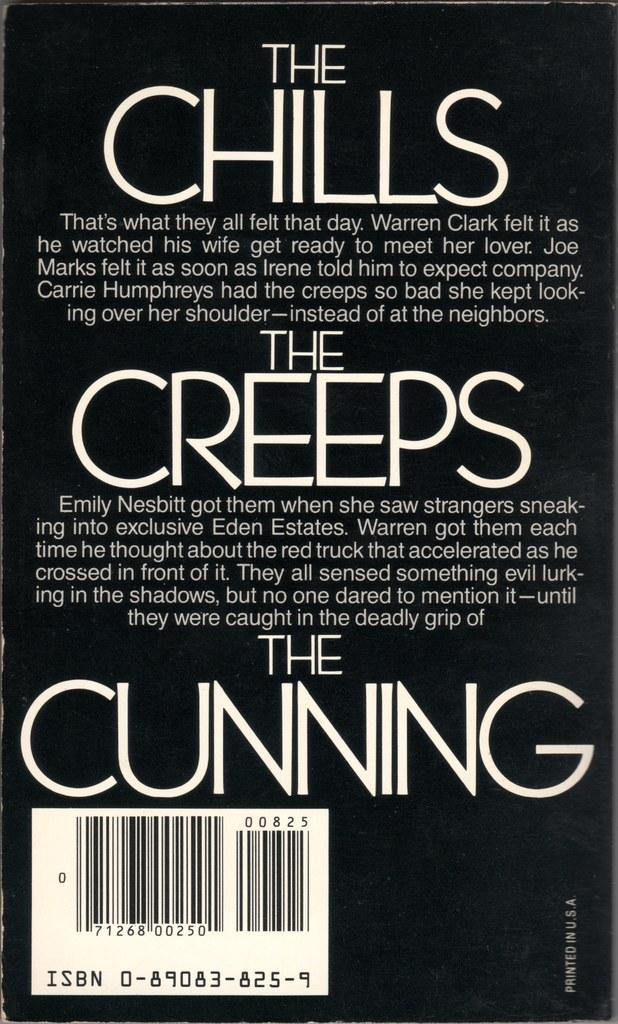What can be found in the image that contains written information? There is some text in the image. What type of symbol is present in the image that is commonly used for tracking products? There is a barcode in the image. Can you describe the squirrel playing in the bushes on the hill in the image? There is no squirrel, bushes, or hill present in the image. 